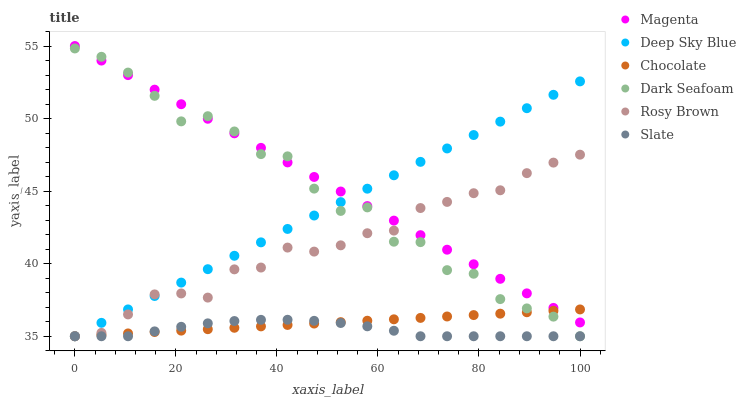Does Slate have the minimum area under the curve?
Answer yes or no. Yes. Does Magenta have the maximum area under the curve?
Answer yes or no. Yes. Does Rosy Brown have the minimum area under the curve?
Answer yes or no. No. Does Rosy Brown have the maximum area under the curve?
Answer yes or no. No. Is Deep Sky Blue the smoothest?
Answer yes or no. Yes. Is Dark Seafoam the roughest?
Answer yes or no. Yes. Is Rosy Brown the smoothest?
Answer yes or no. No. Is Rosy Brown the roughest?
Answer yes or no. No. Does Slate have the lowest value?
Answer yes or no. Yes. Does Magenta have the lowest value?
Answer yes or no. No. Does Magenta have the highest value?
Answer yes or no. Yes. Does Rosy Brown have the highest value?
Answer yes or no. No. Is Slate less than Magenta?
Answer yes or no. Yes. Is Magenta greater than Slate?
Answer yes or no. Yes. Does Slate intersect Deep Sky Blue?
Answer yes or no. Yes. Is Slate less than Deep Sky Blue?
Answer yes or no. No. Is Slate greater than Deep Sky Blue?
Answer yes or no. No. Does Slate intersect Magenta?
Answer yes or no. No. 